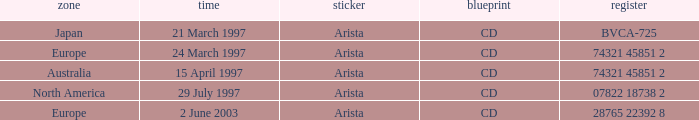What's the Date for the Region of Europe and has the Catalog of 28765 22392 8? 2 June 2003. 